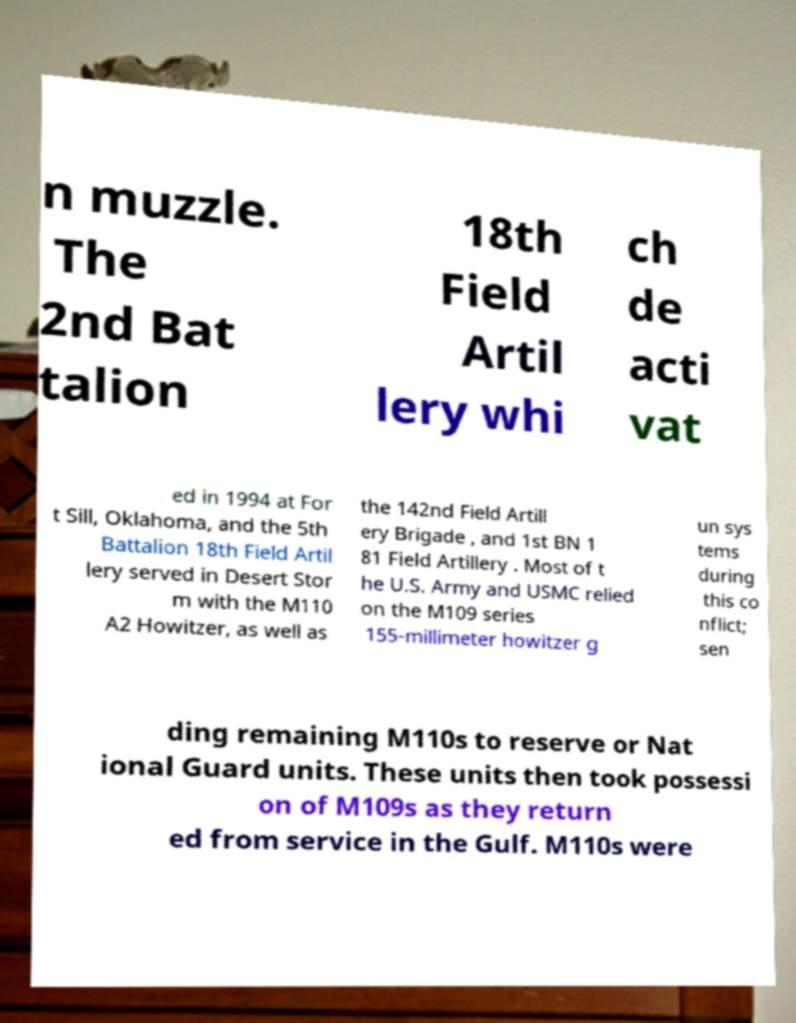For documentation purposes, I need the text within this image transcribed. Could you provide that? n muzzle. The 2nd Bat talion 18th Field Artil lery whi ch de acti vat ed in 1994 at For t Sill, Oklahoma, and the 5th Battalion 18th Field Artil lery served in Desert Stor m with the M110 A2 Howitzer, as well as the 142nd Field Artill ery Brigade , and 1st BN 1 81 Field Artillery . Most of t he U.S. Army and USMC relied on the M109 series 155-millimeter howitzer g un sys tems during this co nflict; sen ding remaining M110s to reserve or Nat ional Guard units. These units then took possessi on of M109s as they return ed from service in the Gulf. M110s were 